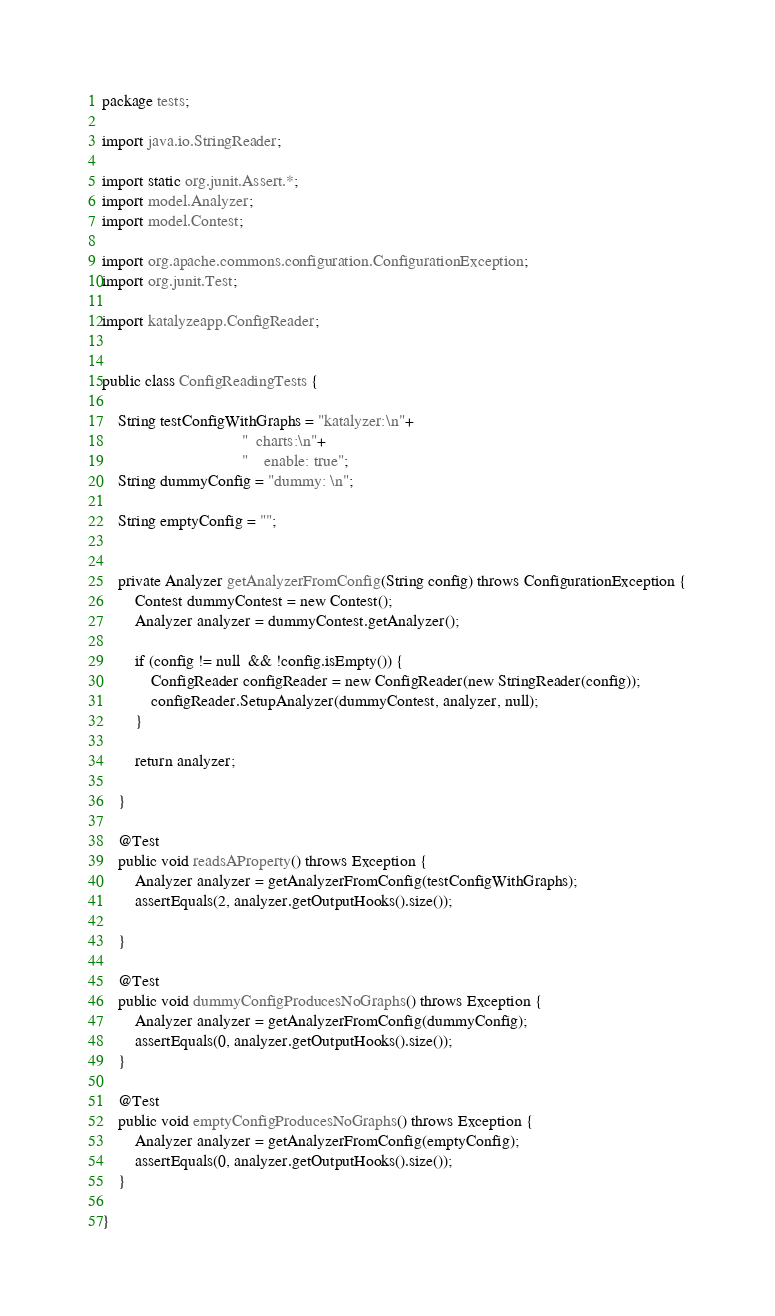Convert code to text. <code><loc_0><loc_0><loc_500><loc_500><_Java_>package tests;

import java.io.StringReader;

import static org.junit.Assert.*;
import model.Analyzer;
import model.Contest;

import org.apache.commons.configuration.ConfigurationException;
import org.junit.Test;

import katalyzeapp.ConfigReader;


public class ConfigReadingTests {
	
	String testConfigWithGraphs = "katalyzer:\n"+
								  "  charts:\n"+
								  "    enable: true";
	String dummyConfig = "dummy: \n";

	String emptyConfig = "";
	
	
	private Analyzer getAnalyzerFromConfig(String config) throws ConfigurationException {
		Contest dummyContest = new Contest();
		Analyzer analyzer = dummyContest.getAnalyzer();

		if (config != null  && !config.isEmpty()) {
			ConfigReader configReader = new ConfigReader(new StringReader(config));
			configReader.SetupAnalyzer(dummyContest, analyzer, null);
		}

		return analyzer;
		
	}
	
	@Test
	public void readsAProperty() throws Exception {
		Analyzer analyzer = getAnalyzerFromConfig(testConfigWithGraphs);
		assertEquals(2, analyzer.getOutputHooks().size());
		
	}
	
	@Test
	public void dummyConfigProducesNoGraphs() throws Exception {
		Analyzer analyzer = getAnalyzerFromConfig(dummyConfig);
		assertEquals(0, analyzer.getOutputHooks().size());
	}

	@Test
	public void emptyConfigProducesNoGraphs() throws Exception {
		Analyzer analyzer = getAnalyzerFromConfig(emptyConfig);
		assertEquals(0, analyzer.getOutputHooks().size());
	}

}
</code> 